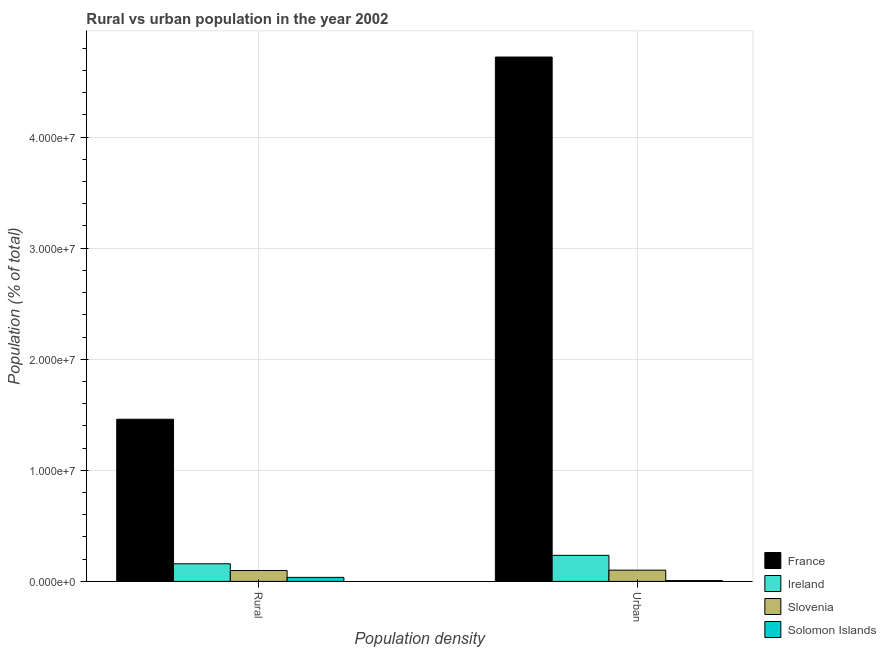How many groups of bars are there?
Ensure brevity in your answer.  2. How many bars are there on the 1st tick from the right?
Keep it short and to the point. 4. What is the label of the 2nd group of bars from the left?
Your answer should be very brief. Urban. What is the rural population density in France?
Provide a short and direct response. 1.46e+07. Across all countries, what is the maximum rural population density?
Your response must be concise. 1.46e+07. Across all countries, what is the minimum rural population density?
Offer a very short reply. 3.63e+05. In which country was the urban population density maximum?
Provide a short and direct response. France. In which country was the rural population density minimum?
Keep it short and to the point. Solomon Islands. What is the total urban population density in the graph?
Make the answer very short. 5.06e+07. What is the difference between the rural population density in Slovenia and that in Solomon Islands?
Offer a terse response. 6.19e+05. What is the difference between the rural population density in Slovenia and the urban population density in Solomon Islands?
Your answer should be very brief. 9.10e+05. What is the average urban population density per country?
Offer a very short reply. 1.27e+07. What is the difference between the urban population density and rural population density in Ireland?
Your answer should be compact. 7.59e+05. What is the ratio of the urban population density in France to that in Solomon Islands?
Your answer should be very brief. 654.02. Is the rural population density in Ireland less than that in France?
Give a very brief answer. Yes. In how many countries, is the rural population density greater than the average rural population density taken over all countries?
Your answer should be compact. 1. What does the 3rd bar from the left in Urban represents?
Your answer should be compact. Slovenia. How many bars are there?
Give a very brief answer. 8. How many countries are there in the graph?
Make the answer very short. 4. What is the difference between two consecutive major ticks on the Y-axis?
Your answer should be compact. 1.00e+07. Are the values on the major ticks of Y-axis written in scientific E-notation?
Give a very brief answer. Yes. Does the graph contain any zero values?
Your response must be concise. No. Where does the legend appear in the graph?
Make the answer very short. Bottom right. How are the legend labels stacked?
Your answer should be compact. Vertical. What is the title of the graph?
Your answer should be very brief. Rural vs urban population in the year 2002. What is the label or title of the X-axis?
Offer a terse response. Population density. What is the label or title of the Y-axis?
Ensure brevity in your answer.  Population (% of total). What is the Population (% of total) in France in Rural?
Ensure brevity in your answer.  1.46e+07. What is the Population (% of total) in Ireland in Rural?
Make the answer very short. 1.59e+06. What is the Population (% of total) in Slovenia in Rural?
Offer a very short reply. 9.82e+05. What is the Population (% of total) in Solomon Islands in Rural?
Offer a very short reply. 3.63e+05. What is the Population (% of total) of France in Urban?
Ensure brevity in your answer.  4.72e+07. What is the Population (% of total) of Ireland in Urban?
Make the answer very short. 2.35e+06. What is the Population (% of total) in Slovenia in Urban?
Give a very brief answer. 1.01e+06. What is the Population (% of total) in Solomon Islands in Urban?
Provide a short and direct response. 7.22e+04. Across all Population density, what is the maximum Population (% of total) of France?
Your response must be concise. 4.72e+07. Across all Population density, what is the maximum Population (% of total) of Ireland?
Make the answer very short. 2.35e+06. Across all Population density, what is the maximum Population (% of total) of Slovenia?
Your answer should be very brief. 1.01e+06. Across all Population density, what is the maximum Population (% of total) in Solomon Islands?
Your answer should be compact. 3.63e+05. Across all Population density, what is the minimum Population (% of total) of France?
Ensure brevity in your answer.  1.46e+07. Across all Population density, what is the minimum Population (% of total) of Ireland?
Offer a very short reply. 1.59e+06. Across all Population density, what is the minimum Population (% of total) in Slovenia?
Provide a succinct answer. 9.82e+05. Across all Population density, what is the minimum Population (% of total) in Solomon Islands?
Make the answer very short. 7.22e+04. What is the total Population (% of total) of France in the graph?
Offer a very short reply. 6.18e+07. What is the total Population (% of total) of Ireland in the graph?
Provide a succinct answer. 3.93e+06. What is the total Population (% of total) in Slovenia in the graph?
Make the answer very short. 1.99e+06. What is the total Population (% of total) in Solomon Islands in the graph?
Give a very brief answer. 4.35e+05. What is the difference between the Population (% of total) of France in Rural and that in Urban?
Offer a very short reply. -3.26e+07. What is the difference between the Population (% of total) of Ireland in Rural and that in Urban?
Offer a very short reply. -7.59e+05. What is the difference between the Population (% of total) of Slovenia in Rural and that in Urban?
Your answer should be compact. -3.10e+04. What is the difference between the Population (% of total) in Solomon Islands in Rural and that in Urban?
Your answer should be very brief. 2.91e+05. What is the difference between the Population (% of total) in France in Rural and the Population (% of total) in Ireland in Urban?
Make the answer very short. 1.23e+07. What is the difference between the Population (% of total) of France in Rural and the Population (% of total) of Slovenia in Urban?
Your answer should be very brief. 1.36e+07. What is the difference between the Population (% of total) of France in Rural and the Population (% of total) of Solomon Islands in Urban?
Make the answer very short. 1.45e+07. What is the difference between the Population (% of total) of Ireland in Rural and the Population (% of total) of Slovenia in Urban?
Give a very brief answer. 5.74e+05. What is the difference between the Population (% of total) of Ireland in Rural and the Population (% of total) of Solomon Islands in Urban?
Your answer should be compact. 1.51e+06. What is the difference between the Population (% of total) of Slovenia in Rural and the Population (% of total) of Solomon Islands in Urban?
Your response must be concise. 9.10e+05. What is the average Population (% of total) of France per Population density?
Ensure brevity in your answer.  3.09e+07. What is the average Population (% of total) in Ireland per Population density?
Keep it short and to the point. 1.97e+06. What is the average Population (% of total) in Slovenia per Population density?
Provide a short and direct response. 9.97e+05. What is the average Population (% of total) in Solomon Islands per Population density?
Make the answer very short. 2.17e+05. What is the difference between the Population (% of total) of France and Population (% of total) of Ireland in Rural?
Give a very brief answer. 1.30e+07. What is the difference between the Population (% of total) in France and Population (% of total) in Slovenia in Rural?
Provide a succinct answer. 1.36e+07. What is the difference between the Population (% of total) of France and Population (% of total) of Solomon Islands in Rural?
Make the answer very short. 1.42e+07. What is the difference between the Population (% of total) of Ireland and Population (% of total) of Slovenia in Rural?
Make the answer very short. 6.05e+05. What is the difference between the Population (% of total) in Ireland and Population (% of total) in Solomon Islands in Rural?
Your answer should be compact. 1.22e+06. What is the difference between the Population (% of total) in Slovenia and Population (% of total) in Solomon Islands in Rural?
Give a very brief answer. 6.19e+05. What is the difference between the Population (% of total) in France and Population (% of total) in Ireland in Urban?
Give a very brief answer. 4.49e+07. What is the difference between the Population (% of total) in France and Population (% of total) in Slovenia in Urban?
Ensure brevity in your answer.  4.62e+07. What is the difference between the Population (% of total) of France and Population (% of total) of Solomon Islands in Urban?
Ensure brevity in your answer.  4.71e+07. What is the difference between the Population (% of total) in Ireland and Population (% of total) in Slovenia in Urban?
Give a very brief answer. 1.33e+06. What is the difference between the Population (% of total) in Ireland and Population (% of total) in Solomon Islands in Urban?
Keep it short and to the point. 2.27e+06. What is the difference between the Population (% of total) in Slovenia and Population (% of total) in Solomon Islands in Urban?
Provide a short and direct response. 9.41e+05. What is the ratio of the Population (% of total) in France in Rural to that in Urban?
Provide a short and direct response. 0.31. What is the ratio of the Population (% of total) in Ireland in Rural to that in Urban?
Provide a succinct answer. 0.68. What is the ratio of the Population (% of total) of Slovenia in Rural to that in Urban?
Offer a very short reply. 0.97. What is the ratio of the Population (% of total) in Solomon Islands in Rural to that in Urban?
Offer a very short reply. 5.03. What is the difference between the highest and the second highest Population (% of total) of France?
Your answer should be compact. 3.26e+07. What is the difference between the highest and the second highest Population (% of total) in Ireland?
Ensure brevity in your answer.  7.59e+05. What is the difference between the highest and the second highest Population (% of total) of Slovenia?
Your response must be concise. 3.10e+04. What is the difference between the highest and the second highest Population (% of total) of Solomon Islands?
Your answer should be compact. 2.91e+05. What is the difference between the highest and the lowest Population (% of total) of France?
Provide a succinct answer. 3.26e+07. What is the difference between the highest and the lowest Population (% of total) in Ireland?
Offer a very short reply. 7.59e+05. What is the difference between the highest and the lowest Population (% of total) in Slovenia?
Your response must be concise. 3.10e+04. What is the difference between the highest and the lowest Population (% of total) in Solomon Islands?
Your answer should be very brief. 2.91e+05. 